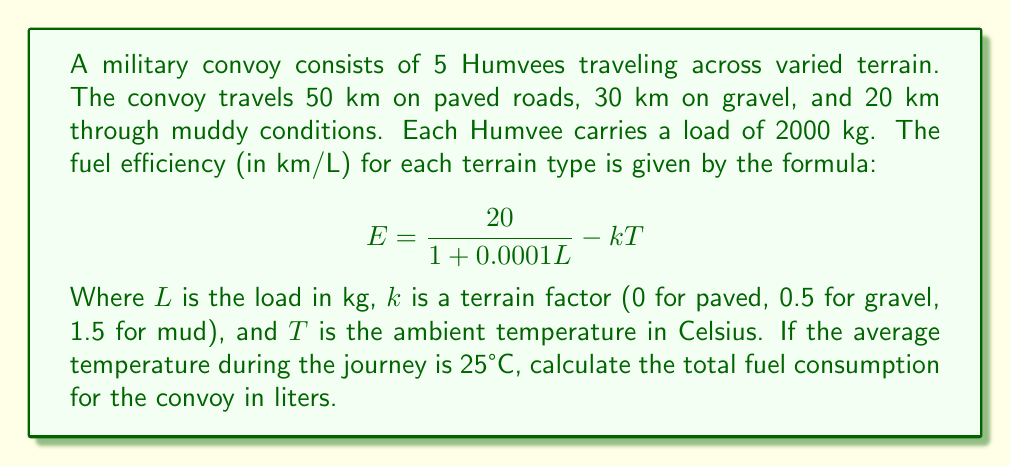Can you solve this math problem? Let's approach this step-by-step:

1) First, we need to calculate the fuel efficiency for each terrain type:

   For paved roads: 
   $$E_{paved} = \frac{20}{1 + 0.0001(2000)} - 0(25) = 16.67 \text{ km/L}$$

   For gravel:
   $$E_{gravel} = \frac{20}{1 + 0.0001(2000)} - 0.5(25) = 4.17 \text{ km/L}$$

   For muddy conditions:
   $$E_{mud} = \frac{20}{1 + 0.0001(2000)} - 1.5(25) = -20.83 \text{ km/L}$$
   
   Note: The negative efficiency for mud indicates the vehicle can't move in these conditions. We'll assume a minimum efficiency of 1 km/L for mud.

2) Now, let's calculate the fuel consumption for each terrain type:

   Paved: $\frac{50 \text{ km}}{16.67 \text{ km/L}} = 3 \text{ L}$
   
   Gravel: $\frac{30 \text{ km}}{4.17 \text{ km/L}} = 7.19 \text{ L}$
   
   Mud: $\frac{20 \text{ km}}{1 \text{ km/L}} = 20 \text{ L}$

3) Total fuel consumption for one Humvee:

   $3 + 7.19 + 20 = 30.19 \text{ L}$

4) For the entire convoy of 5 Humvees:

   $30.19 \text{ L} \times 5 = 150.95 \text{ L}$
Answer: 150.95 L 